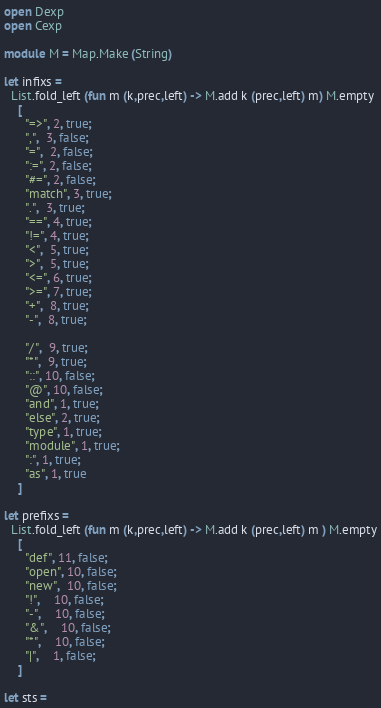<code> <loc_0><loc_0><loc_500><loc_500><_OCaml_>open Dexp
open Cexp

module M = Map.Make (String)

let infixs =
  List.fold_left (fun m (k,prec,left) -> M.add k (prec,left) m) M.empty
    [
      "=>", 2, true;
      ",",  3, false;
      "=",  2, false;
      ":=", 2, false;
      "#=", 2, false;
      "match", 3, true;
      ".",  3, true;
      "==", 4, true;
      "!=", 4, true;
      "<",  5, true;
      ">",  5, true;
      "<=", 6, true;
      ">=", 7, true;
      "+",  8, true;
      "-",  8, true;

      "/",  9, true;
      "*",  9, true;
      "::", 10, false;
      "@", 10, false;
      "and", 1, true;
      "else", 2, true;
      "type", 1, true;
      "module", 1, true;
      ":", 1, true;
      "as", 1, true 
    ]

let prefixs =
  List.fold_left (fun m (k,prec,left) -> M.add k (prec,left) m ) M.empty
    [
      "def", 11, false;
      "open", 10, false;
      "new",  10, false;
      "!",    10, false;
      "-",    10, false;
      "&",    10, false;
      "*",    10, false;
      "|",    1, false;
    ]

let sts =</code> 